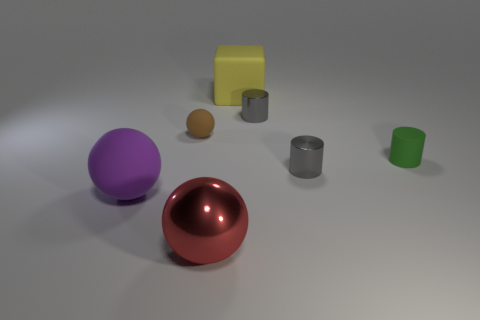Subtract all tiny gray metal cylinders. How many cylinders are left? 1 Add 2 large matte things. How many objects exist? 9 Subtract all purple spheres. How many spheres are left? 2 Subtract 1 cylinders. How many cylinders are left? 2 Subtract all cubes. How many objects are left? 6 Subtract all red spheres. How many gray cylinders are left? 2 Add 2 green rubber cylinders. How many green rubber cylinders exist? 3 Subtract 1 purple balls. How many objects are left? 6 Subtract all gray balls. Subtract all yellow cubes. How many balls are left? 3 Subtract all tiny cylinders. Subtract all cylinders. How many objects are left? 1 